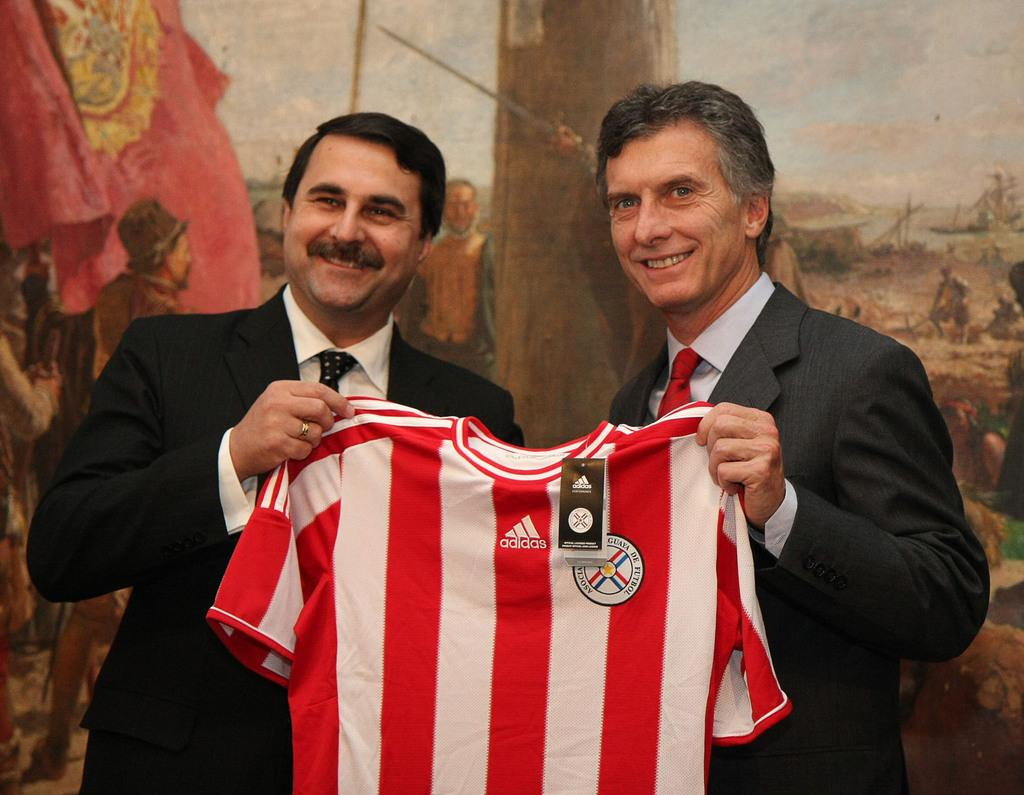<image>
Summarize the visual content of the image. The red jersey has the ad from Adidas on it 